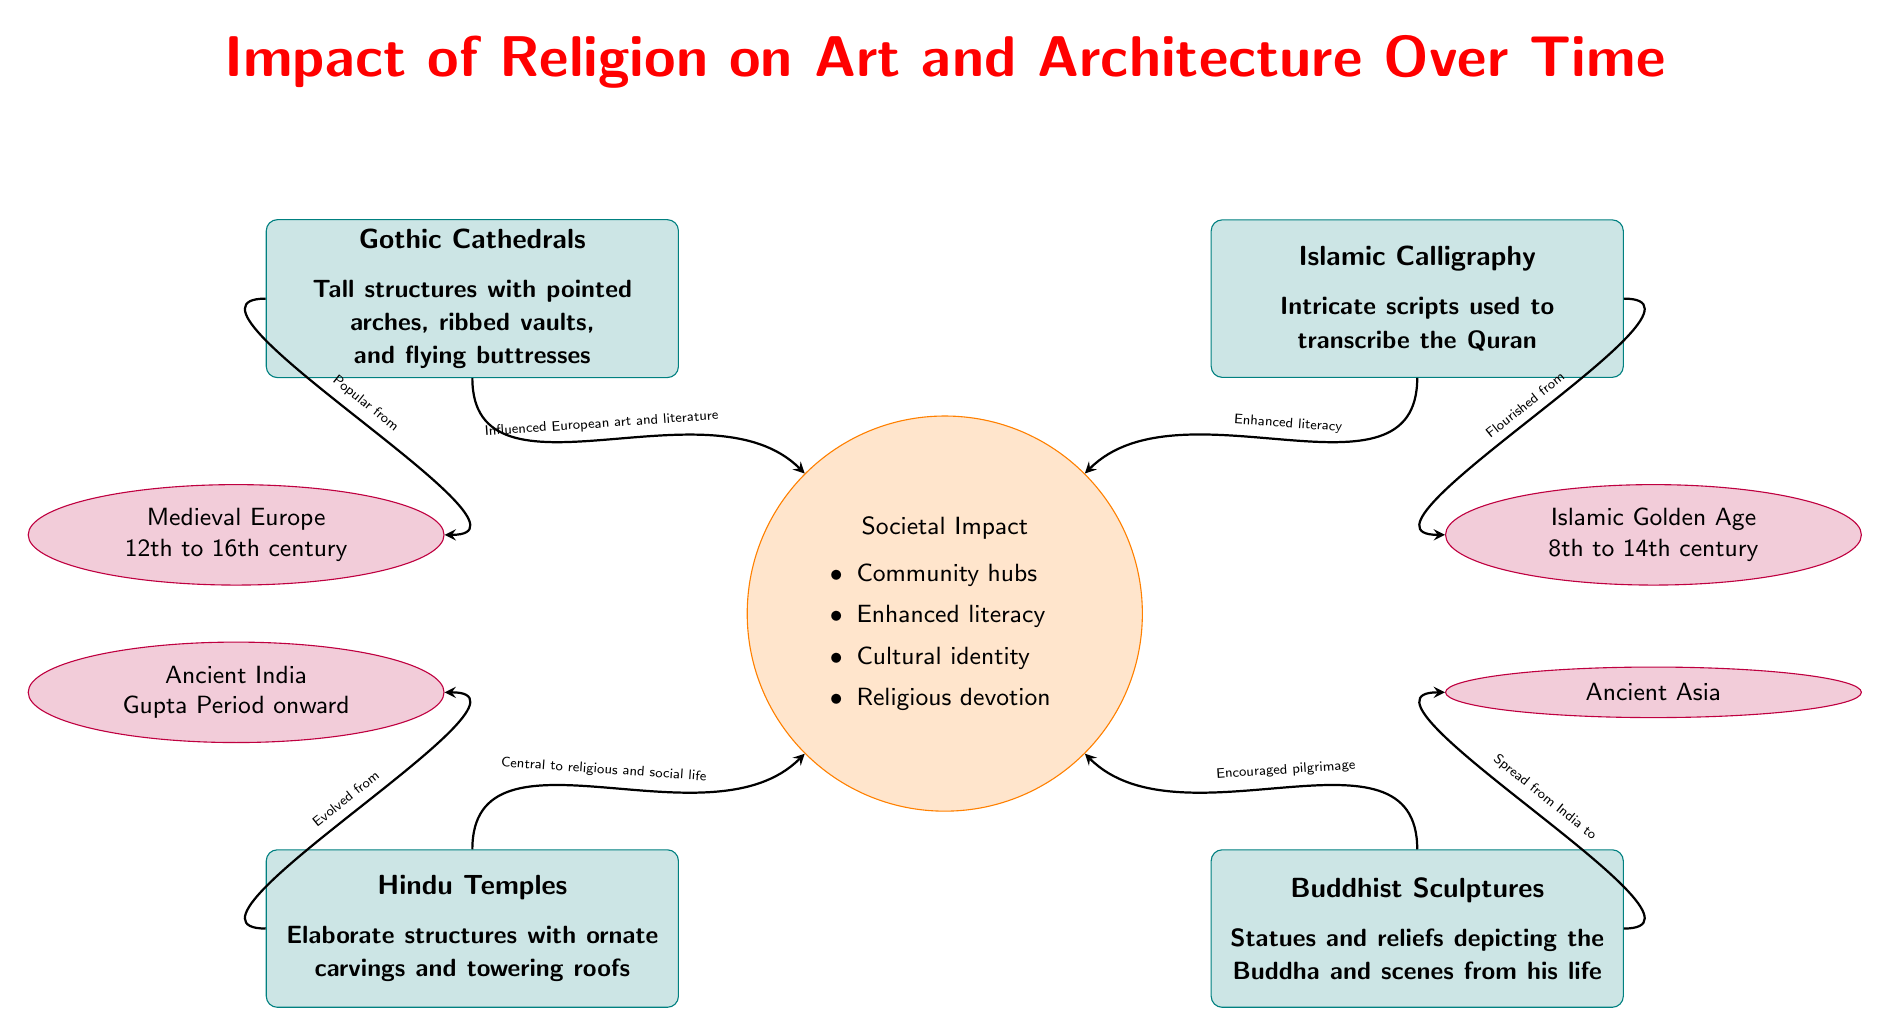What are the four major art styles displayed in the diagram? The diagram shows four major art styles: Gothic Cathedrals, Islamic Calligraphy, Hindu Temples, and Buddhist Sculptures. These can be found in the left and right sections of the diagram.
Answer: Gothic Cathedrals, Islamic Calligraphy, Hindu Temples, Buddhist Sculptures During which era did Gothic Cathedrals become popular? According to the diagram, Gothic Cathedrals were popular during the Medieval Europe era, which spans from the 12th to the 16th century. This information is connected through the arrow from Gothic Cathedrals to the Medieval Europe node.
Answer: 12th to 16th century What societal impact did Islamic Calligraphy have? The diagram indicates that Islamic Calligraphy contributed to enhanced literacy. This relationship is shown by the arrow connecting Islamic Calligraphy to the societal impact node labeled 'Enhanced literacy.'
Answer: Enhanced literacy How did Hindu Temples evolve? The diagram states that Hindu Temples evolved from Ancient India, as indicated by the arrow linking Hindu Temples to the Ancient India node, which signifies the geographical and historical progression.
Answer: Ancient India What specific implication does Gothic Cathedrals have on European art? The diagram notes that Gothic Cathedrals influenced European art and literature. This is shown through the arrow leading from Gothic Cathedrals to the societal impact node describing this influence.
Answer: Influenced European art and literature What is one common societal implication shared by all art styles in the diagram? The diagram shows that a common societal implication for all art styles is their role as community hubs, as indicated in the societal impact section which groups these various influences together.
Answer: Community hubs 